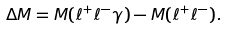Convert formula to latex. <formula><loc_0><loc_0><loc_500><loc_500>\Delta M = M ( \ell ^ { + } \ell ^ { - } \gamma ) - M ( \ell ^ { + } \ell ^ { - } ) .</formula> 